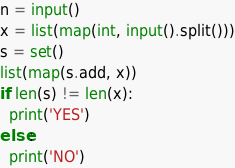Convert code to text. <code><loc_0><loc_0><loc_500><loc_500><_Python_>n = input()
x = list(map(int, input().split()))
s = set()
list(map(s.add, x))
if len(s) != len(x):
  print('YES')
else:
  print('NO')
</code> 